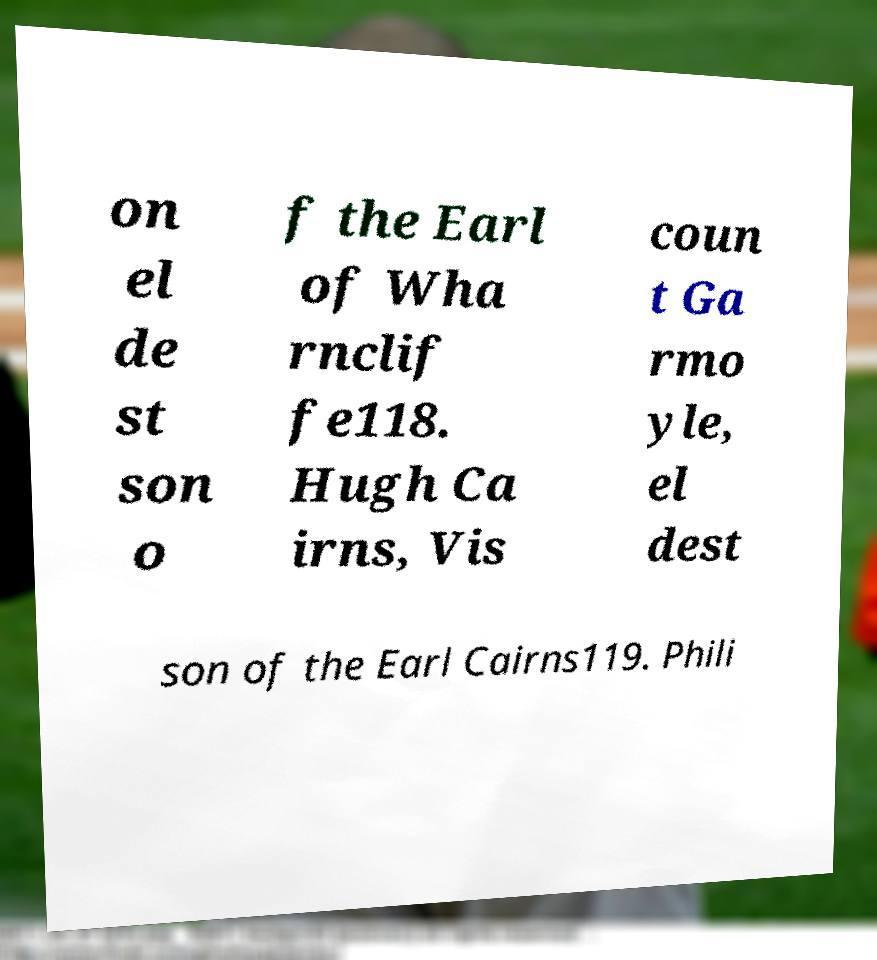Please identify and transcribe the text found in this image. on el de st son o f the Earl of Wha rnclif fe118. Hugh Ca irns, Vis coun t Ga rmo yle, el dest son of the Earl Cairns119. Phili 